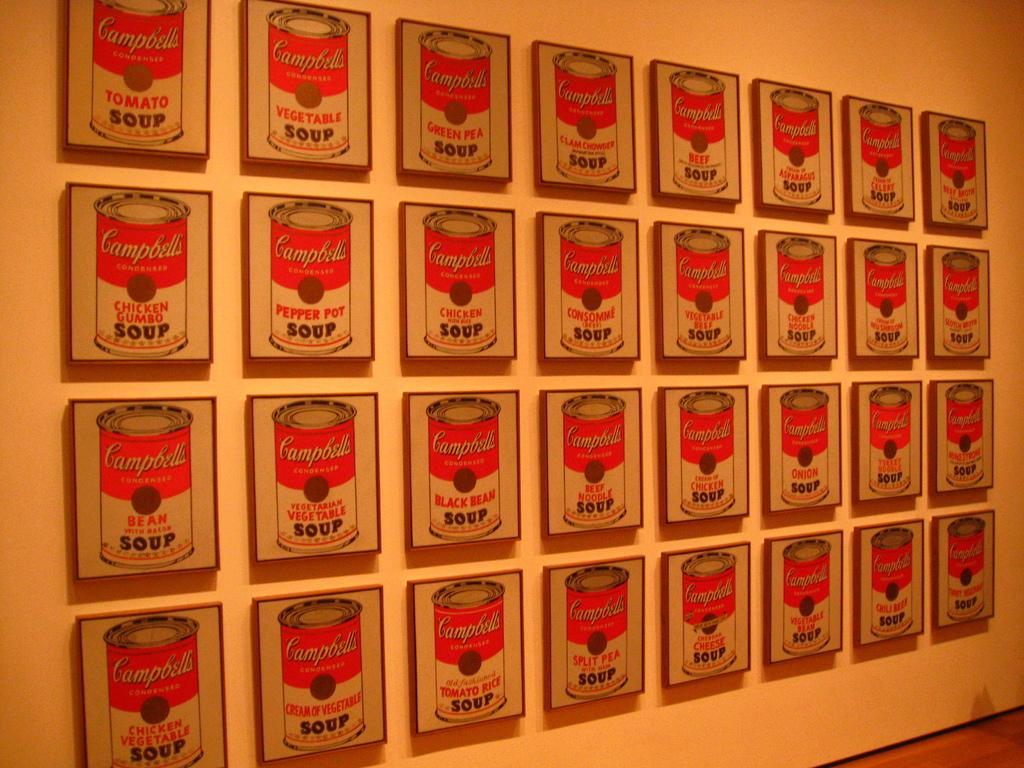<image>
Create a compact narrative representing the image presented. some photos of soup cans that are on the wall 